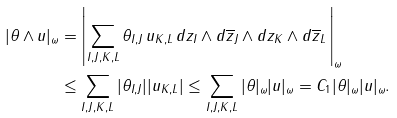<formula> <loc_0><loc_0><loc_500><loc_500>| \theta \wedge u | _ { \omega } & = \left | \sum _ { I , J , K , L } \theta _ { I , J } \, u _ { K , L } \, d z _ { I } \wedge d \overline { z } _ { J } \wedge d z _ { K } \wedge d \overline { z } _ { L } \, \right | _ { \omega } \\ & \leq \sum _ { I , J , K , L } | \theta _ { I , J } | | u _ { K , L } | \leq \sum _ { I , J , K , L } | \theta | _ { \omega } | u | _ { \omega } = C _ { 1 } | \theta | _ { \omega } | u | _ { \omega } .</formula> 